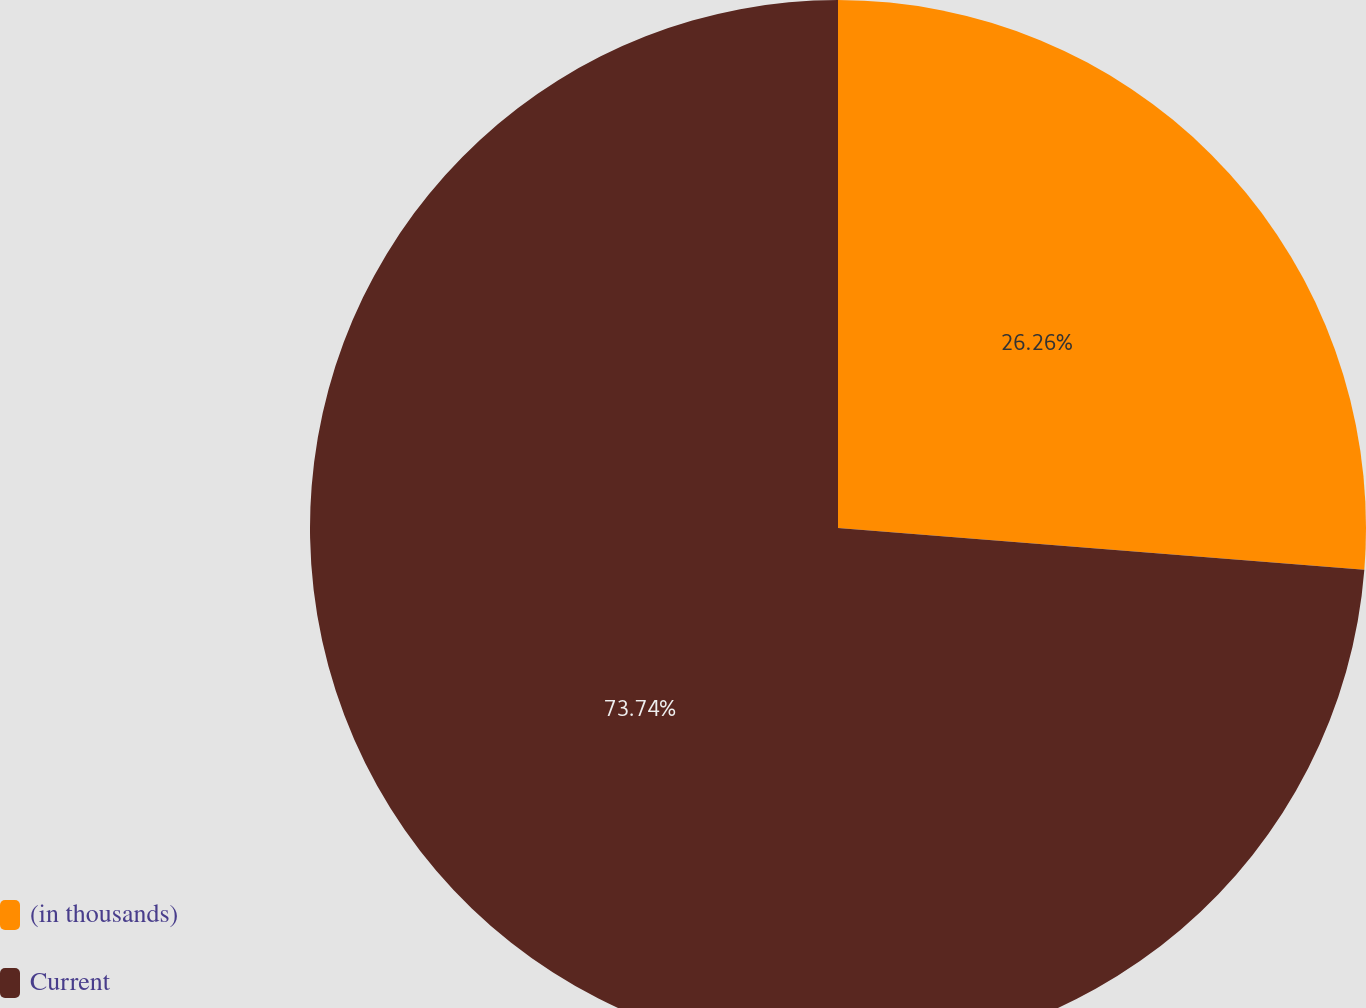<chart> <loc_0><loc_0><loc_500><loc_500><pie_chart><fcel>(in thousands)<fcel>Current<nl><fcel>26.26%<fcel>73.74%<nl></chart> 